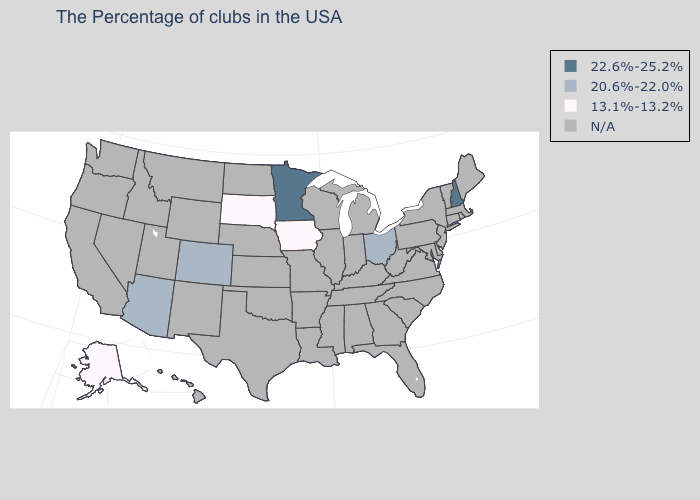Name the states that have a value in the range 20.6%-22.0%?
Keep it brief. Ohio, Colorado, Arizona. Which states have the lowest value in the USA?
Keep it brief. Iowa, South Dakota, Alaska. What is the value of Michigan?
Keep it brief. N/A. Name the states that have a value in the range 22.6%-25.2%?
Answer briefly. New Hampshire, Minnesota. How many symbols are there in the legend?
Quick response, please. 4. Is the legend a continuous bar?
Short answer required. No. What is the value of South Dakota?
Write a very short answer. 13.1%-13.2%. Does the first symbol in the legend represent the smallest category?
Write a very short answer. No. Name the states that have a value in the range N/A?
Write a very short answer. Maine, Massachusetts, Rhode Island, Vermont, Connecticut, New York, New Jersey, Delaware, Maryland, Pennsylvania, Virginia, North Carolina, South Carolina, West Virginia, Florida, Georgia, Michigan, Kentucky, Indiana, Alabama, Tennessee, Wisconsin, Illinois, Mississippi, Louisiana, Missouri, Arkansas, Kansas, Nebraska, Oklahoma, Texas, North Dakota, Wyoming, New Mexico, Utah, Montana, Idaho, Nevada, California, Washington, Oregon, Hawaii. Among the states that border Kentucky , which have the highest value?
Be succinct. Ohio. What is the value of Illinois?
Short answer required. N/A. Which states hav the highest value in the Northeast?
Write a very short answer. New Hampshire. 